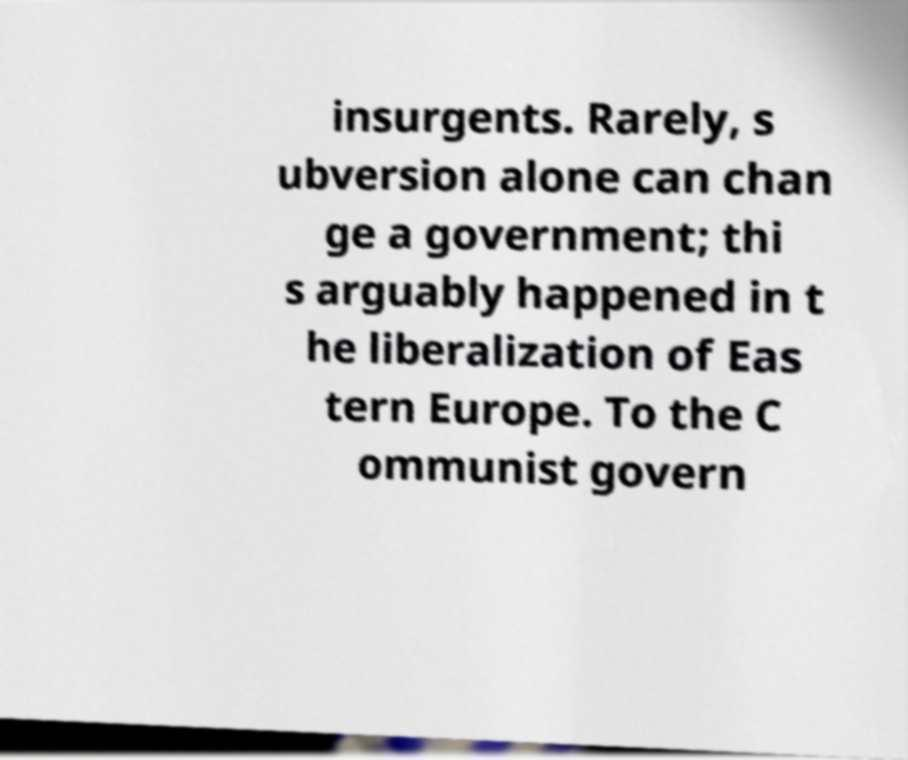Can you accurately transcribe the text from the provided image for me? insurgents. Rarely, s ubversion alone can chan ge a government; thi s arguably happened in t he liberalization of Eas tern Europe. To the C ommunist govern 